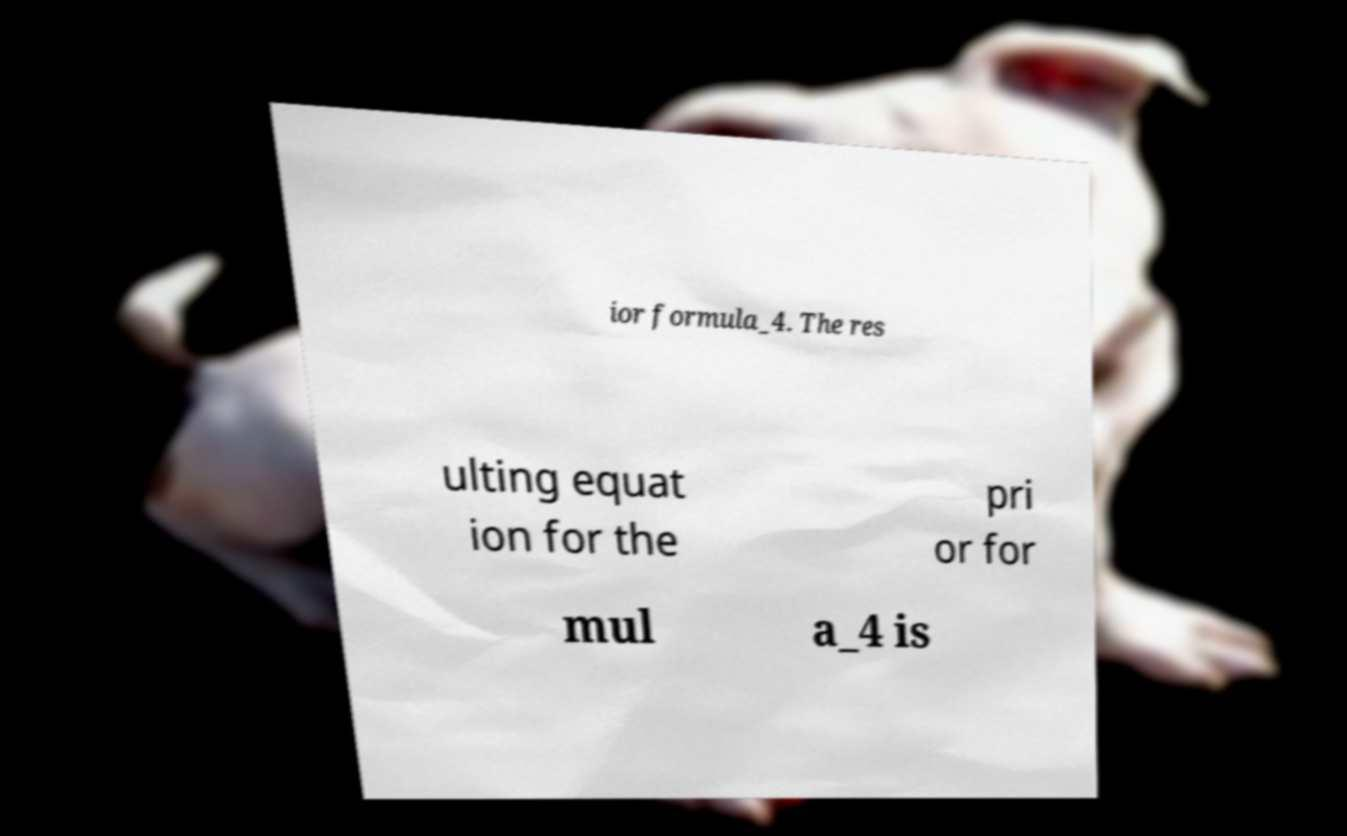Can you accurately transcribe the text from the provided image for me? ior formula_4. The res ulting equat ion for the pri or for mul a_4 is 